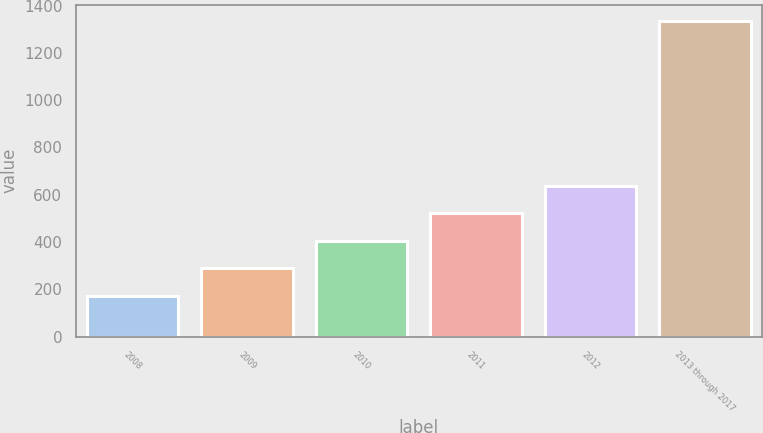Convert chart to OTSL. <chart><loc_0><loc_0><loc_500><loc_500><bar_chart><fcel>2008<fcel>2009<fcel>2010<fcel>2011<fcel>2012<fcel>2013 through 2017<nl><fcel>172<fcel>288.4<fcel>404.8<fcel>521.2<fcel>637.6<fcel>1336<nl></chart> 